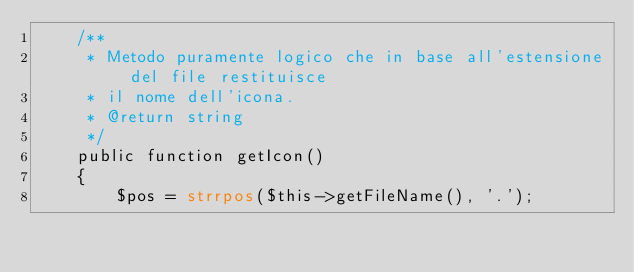<code> <loc_0><loc_0><loc_500><loc_500><_PHP_>    /**
     * Metodo puramente logico che in base all'estensione del file restituisce 
     * il nome dell'icona.
     * @return string
     */
    public function getIcon()
    {
        $pos = strrpos($this->getFileName(), '.');</code> 